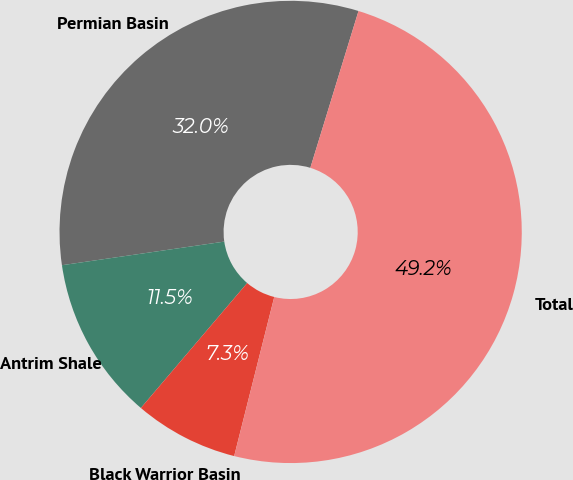<chart> <loc_0><loc_0><loc_500><loc_500><pie_chart><fcel>Permian Basin<fcel>Antrim Shale<fcel>Black Warrior Basin<fcel>Total<nl><fcel>32.04%<fcel>11.48%<fcel>7.29%<fcel>49.18%<nl></chart> 